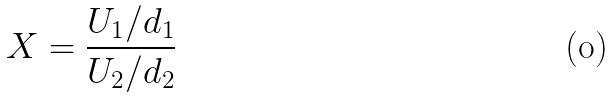<formula> <loc_0><loc_0><loc_500><loc_500>X = \frac { U _ { 1 } / d _ { 1 } } { U _ { 2 } / d _ { 2 } }</formula> 